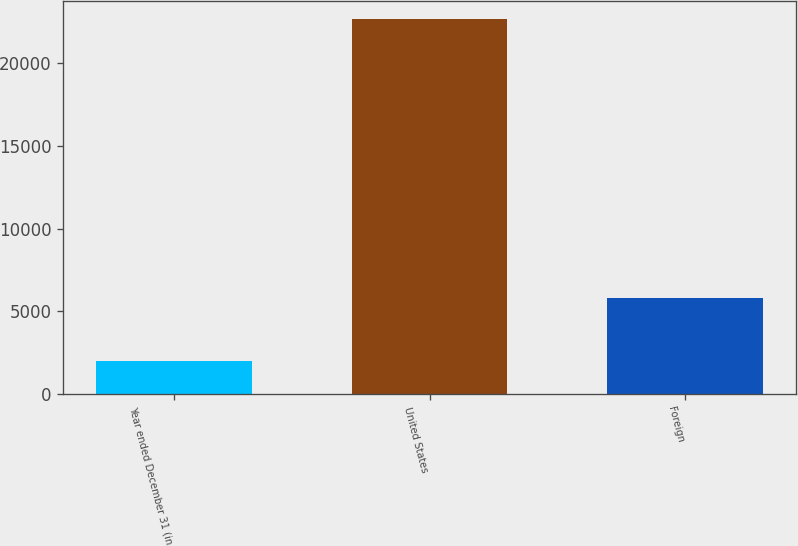<chart> <loc_0><loc_0><loc_500><loc_500><bar_chart><fcel>Year ended December 31 (in<fcel>United States<fcel>Foreign<nl><fcel>2015<fcel>22663<fcel>5799<nl></chart> 